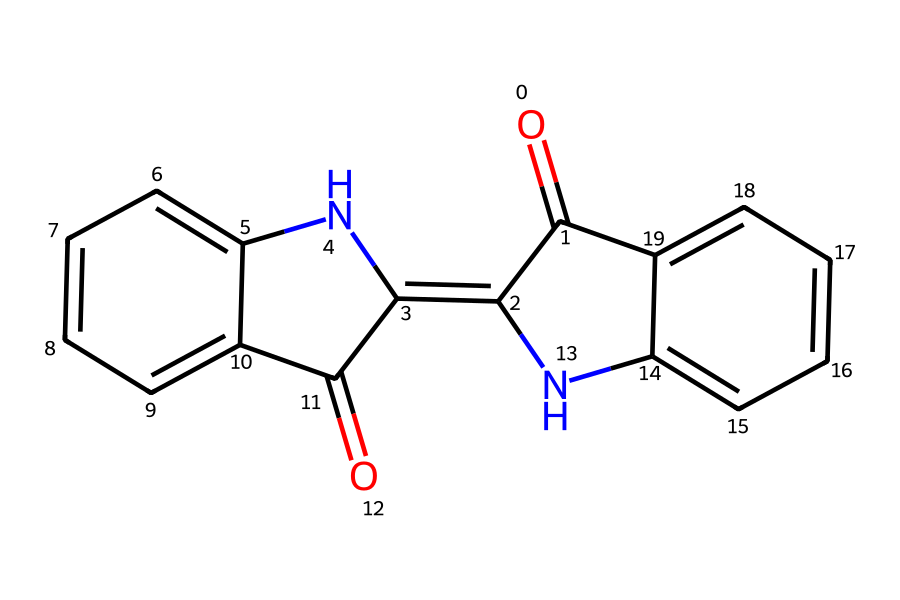What is the molecular formula of indigo dye? To determine the molecular formula, we first analyze the SMILES representation and count the different types of atoms. In the given structure, the number of carbon (C) atoms is 16, hydrogen (H) is 14, nitrogen (N) is 2, and oxygen (O) is 2. Therefore, the molecular formula is C16H14N2O2.
Answer: C16H14N2O2 How many rings are present in the indigo dye structure? By examining the chemical structure, we can observe that there are two interconnected ring systems. Each of the two ring systems contains multiple carbon atoms forming a cyclic structure. Hence, there are 2 rings in total.
Answer: 2 What type of functional groups are present in indigo? Looking at the structure, we can identify functional groups such as the carbonyl (C=O) groups present in the amide portions. In addition to the carbonyls, there are also nitrogen atoms (from amine and amide groups). Therefore, the main functional groups are amides and carbonyls.
Answer: amide, carbonyl How many nitrogen atoms are in the indigo dye? Analyzing the chemical structure reveals two distinct nitrogen (N) atoms within the molecule, which are part of the amine and amide groups. The visual representation confirms that there are two nitrogen atoms present.
Answer: 2 What is the color of indigo dye? Indigo dye is primarily known for its vibrant blue color, which is derived from the chemical properties of its conjugated system of double bonds in the structure. This feature allows it to absorb visible light in a way that reflects blue wavelengths.
Answer: blue 